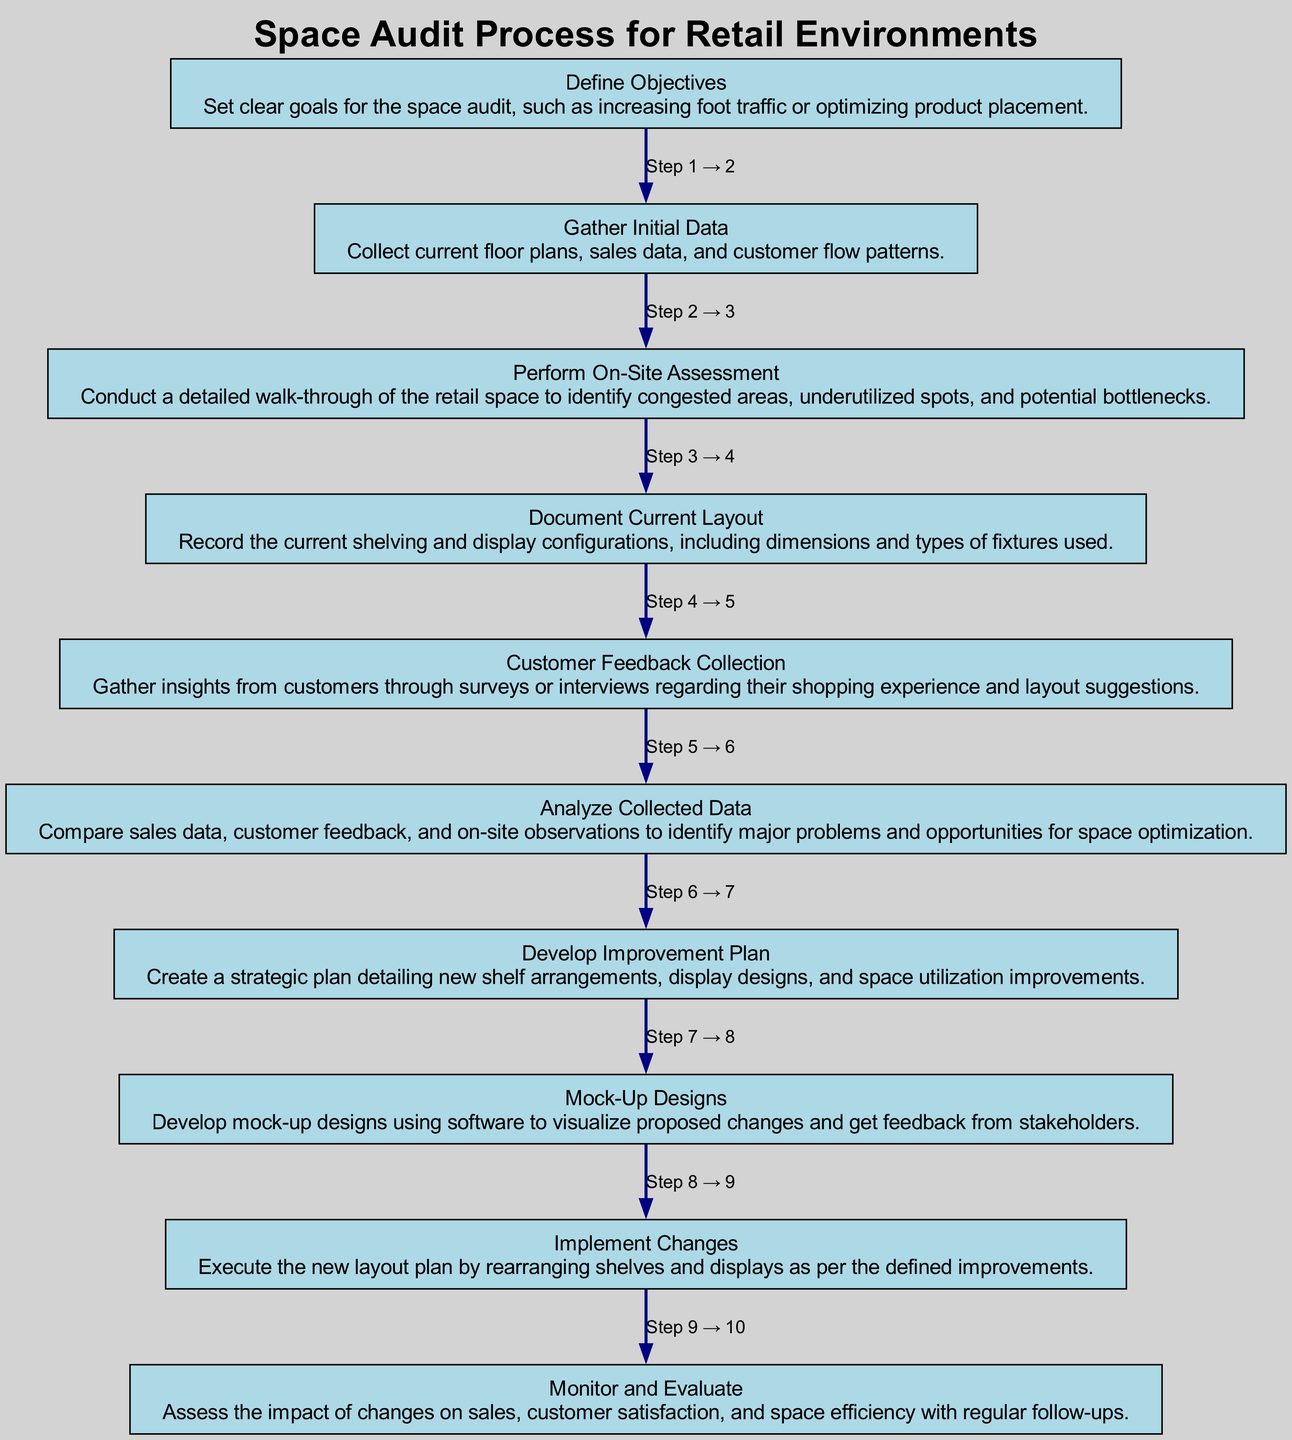What is the first step in the Space Audit Process? The first step, labeled as node "1," is "Define Objectives," which involves setting clear goals for the space audit.
Answer: Define Objectives How many steps are in the Space Audit Process? The diagram contains 10 steps, as indicated by the 10 nodes present in the flowchart.
Answer: 10 Which step comes after "Document Current Layout"? Following "Document Current Layout," which is node "4," the next step is "Customer Feedback Collection," identified as node "5."
Answer: Customer Feedback Collection What is the purpose of the "Analyze Collected Data" step? The "Analyze Collected Data" step, noted as node "6," compares sales data, customer feedback, and observations to identify problems and opportunities for space optimization.
Answer: Identify problems and opportunities Which steps are involved before developing an Improvement Plan? Before developing an Improvement Plan, the steps "Analyze Collected Data," "Customer Feedback Collection," and "Document Current Layout" must be completed; this shows a sequential flow from nodes "5" and "6" leading to "7."
Answer: Steps 5 and 6 What type of feedback is gathered in step "Customer Feedback Collection"? This step specifically focuses on gathering insights from customers through surveys or interviews regarding their shopping experience and layout suggestions.
Answer: Customer insights What is the outcome of the "Implement Changes" step? The outcome involves executing the new layout plan by rearranging shelves and displays according to the defined improvements.
Answer: Execute new layout Explain the relationship between "Develop Improvement Plan" and "Mock-Up Designs." "Develop Improvement Plan," node "7," leads directly to "Mock-Up Designs," node "8," indicating that after developing a strategic plan, the next action is to visualize proposed changes through mock-ups.
Answer: Step 7 leads to Step 8 Which step directly follows "Gather Initial Data"? The step that directly follows "Gather Initial Data," which is node "2," is "Perform On-Site Assessment," identified as node "3."
Answer: Perform On-Site Assessment 